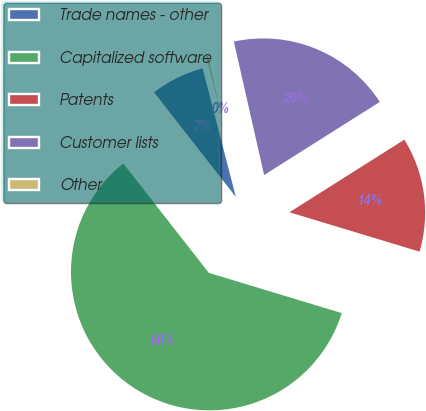Convert chart. <chart><loc_0><loc_0><loc_500><loc_500><pie_chart><fcel>Trade names - other<fcel>Capitalized software<fcel>Patents<fcel>Customer lists<fcel>Other<nl><fcel>6.53%<fcel>59.77%<fcel>13.65%<fcel>19.58%<fcel>0.48%<nl></chart> 